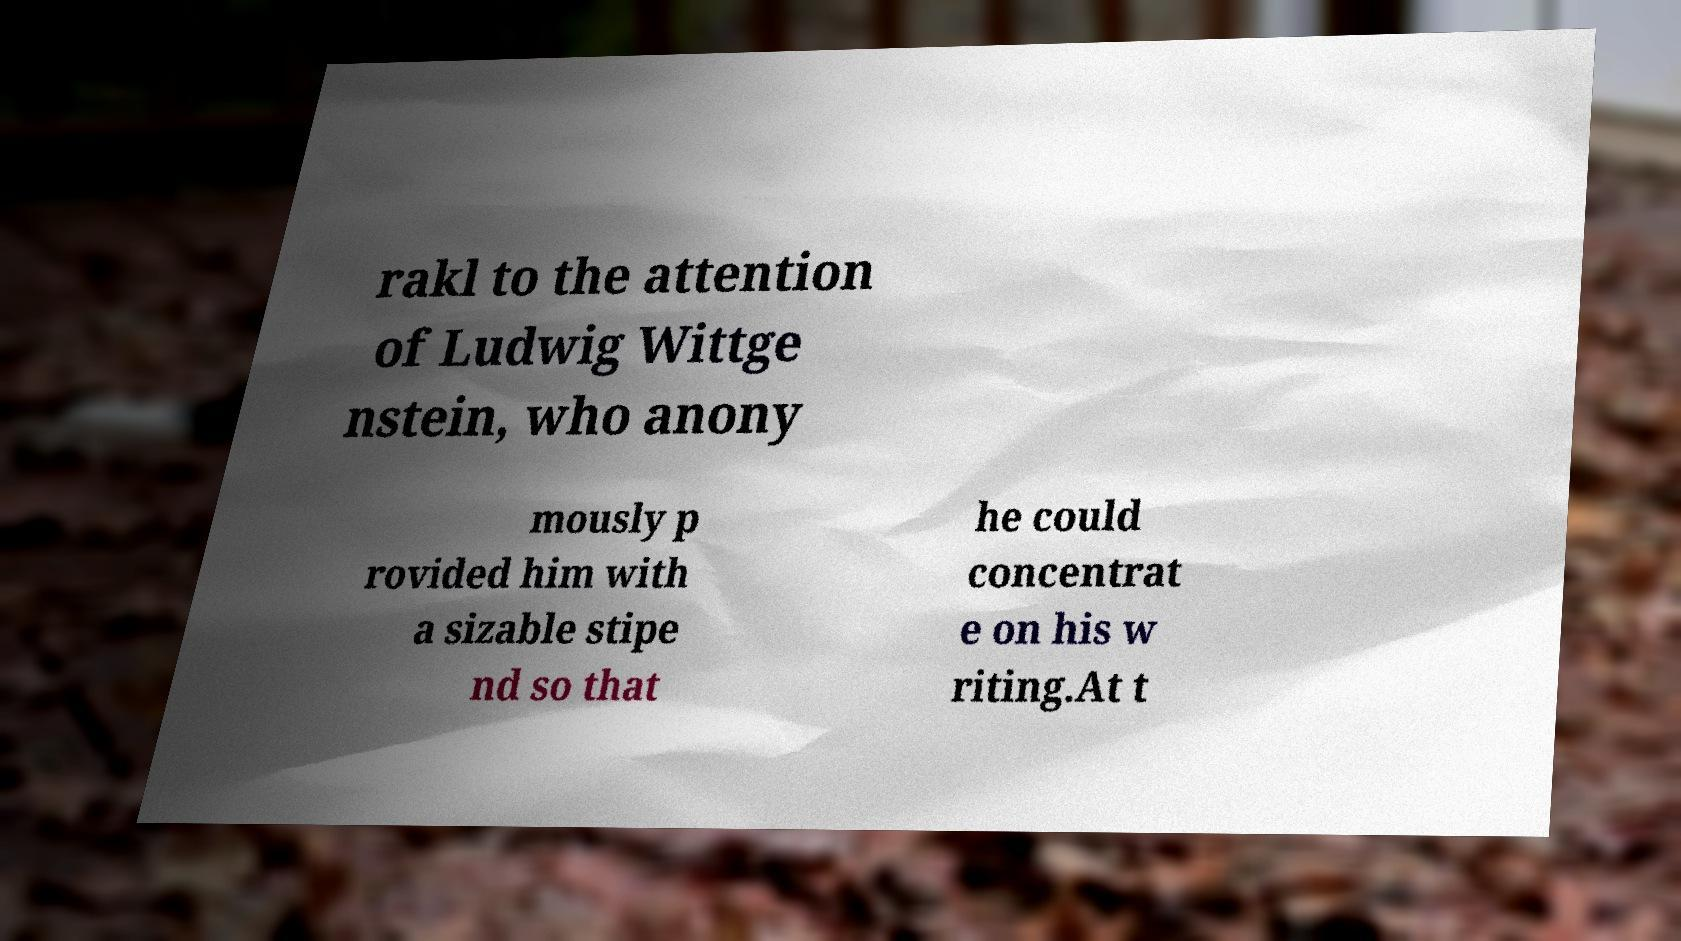Could you extract and type out the text from this image? rakl to the attention of Ludwig Wittge nstein, who anony mously p rovided him with a sizable stipe nd so that he could concentrat e on his w riting.At t 